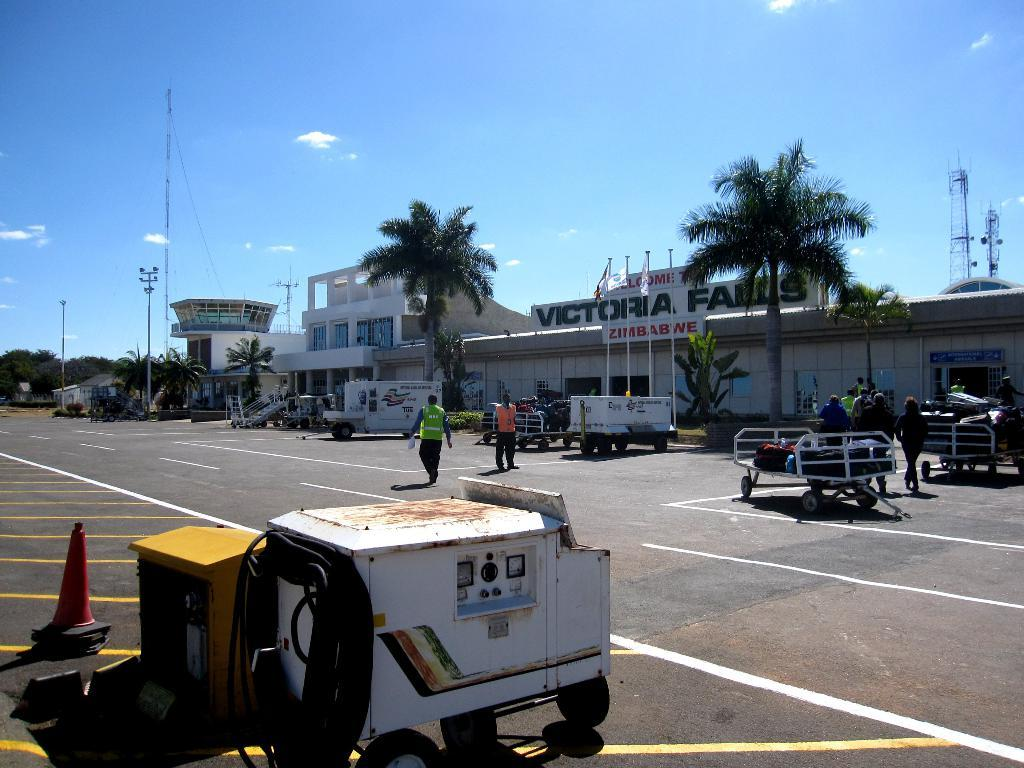What objects are in the image that people might use to transport items? There are carts in the image that people might use to transport items. Can you describe the people in the image? There are people in the image, but their specific actions or characteristics are not mentioned in the facts. What safety or warning device is present on the road in the image? A traffic cone is present on the road in the image. What type of structures can be seen in the background of the image? There are buildings in the background of some kind in the background of the image. What type of vegetation is visible in the background of the image? Trees are visible in the background of the image. What other objects can be seen in the background of the image? Poles and flags are visible in the background of the image. What part of the natural environment is visible in the background of the image? The sky is visible in the background of the image. What type of birthday celebration is taking place in the image? There is no mention of a birthday celebration in the image or the facts provided. 